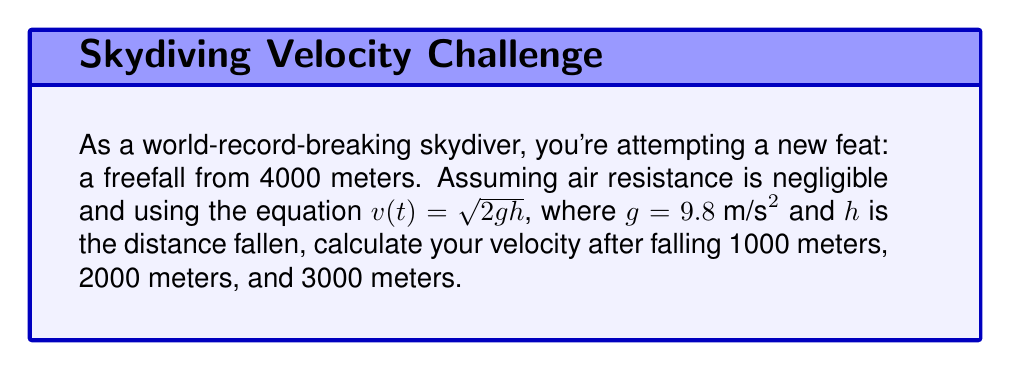Provide a solution to this math problem. To solve this problem, we'll use the equation $v(t) = \sqrt{2gh}$, where:
$v(t)$ is the velocity at time $t$
$g$ is the acceleration due to gravity (9.8 m/s²)
$h$ is the distance fallen

Let's calculate the velocity for each distance:

1. After falling 1000 meters:
   $v = \sqrt{2 \cdot 9.8 \cdot 1000} = \sqrt{19600} \approx 140.0 \text{ m/s}$

2. After falling 2000 meters:
   $v = \sqrt{2 \cdot 9.8 \cdot 2000} = \sqrt{39200} \approx 198.0 \text{ m/s}$

3. After falling 3000 meters:
   $v = \sqrt{2 \cdot 9.8 \cdot 3000} = \sqrt{58800} \approx 242.5 \text{ m/s}$

Note that these calculations assume no air resistance, which is not realistic for actual skydiving. In reality, air resistance would cause the skydiver to reach a terminal velocity, typically around 54 m/s (120 mph) in a belly-to-earth position.
Answer: The velocities at different points during the freefall are:
1. After 1000 meters: $140.0 \text{ m/s}$
2. After 2000 meters: $198.0 \text{ m/s}$
3. After 3000 meters: $242.5 \text{ m/s}$ 